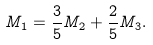<formula> <loc_0><loc_0><loc_500><loc_500>M _ { 1 } = \frac { 3 } { 5 } M _ { 2 } + \frac { 2 } { 5 } M _ { 3 } .</formula> 